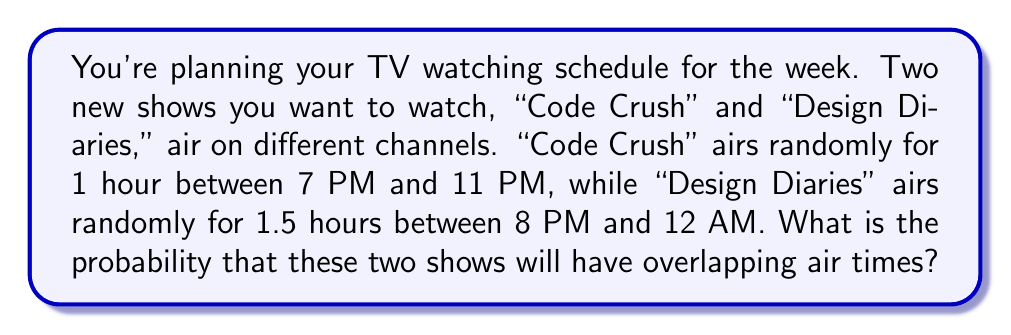Can you answer this question? Let's approach this step-by-step:

1) First, we need to determine the total possible time ranges for each show:
   - "Code Crush": 7 PM to 11 PM = 4 hours
   - "Design Diaries": 8 PM to 12 AM = 4 hours

2) Now, let's consider the possible scenarios:
   a) "Code Crush" starts between 7 PM and 8 PM
   b) "Code Crush" starts between 8 PM and 10:30 PM
   c) "Code Crush" starts between 10:30 PM and 11 PM

3) For scenario a:
   - Probability of "Code Crush" starting in this 1-hour slot: $\frac{1}{4}$
   - For overlap, "Design Diaries" must start before 9 PM
   - Probability of "Design Diaries" starting before 9 PM: $\frac{1}{4}$
   - Probability of overlap in this scenario: $\frac{1}{4} \times \frac{1}{4} = \frac{1}{16}$

4) For scenario b:
   - Probability of "Code Crush" starting in this 2.5-hour slot: $\frac{2.5}{4} = \frac{5}{8}$
   - Any start time of "Design Diaries" will cause overlap
   - Probability of overlap in this scenario: $\frac{5}{8}$

5) For scenario c:
   - Probability of "Code Crush" starting in this 0.5-hour slot: $\frac{0.5}{4} = \frac{1}{8}$
   - For overlap, "Design Diaries" must start before 11:30 PM
   - Probability of "Design Diaries" starting before 11:30 PM: $\frac{3.5}{4}$
   - Probability of overlap in this scenario: $\frac{1}{8} \times \frac{3.5}{4} = \frac{7}{64}$

6) Total probability of overlap:
   $$\frac{1}{16} + \frac{5}{8} + \frac{7}{64} = \frac{4}{64} + \frac{40}{64} + \frac{7}{64} = \frac{51}{64}$$

Therefore, the probability of the two shows having overlapping air times is $\frac{51}{64}$.
Answer: $\frac{51}{64}$ 